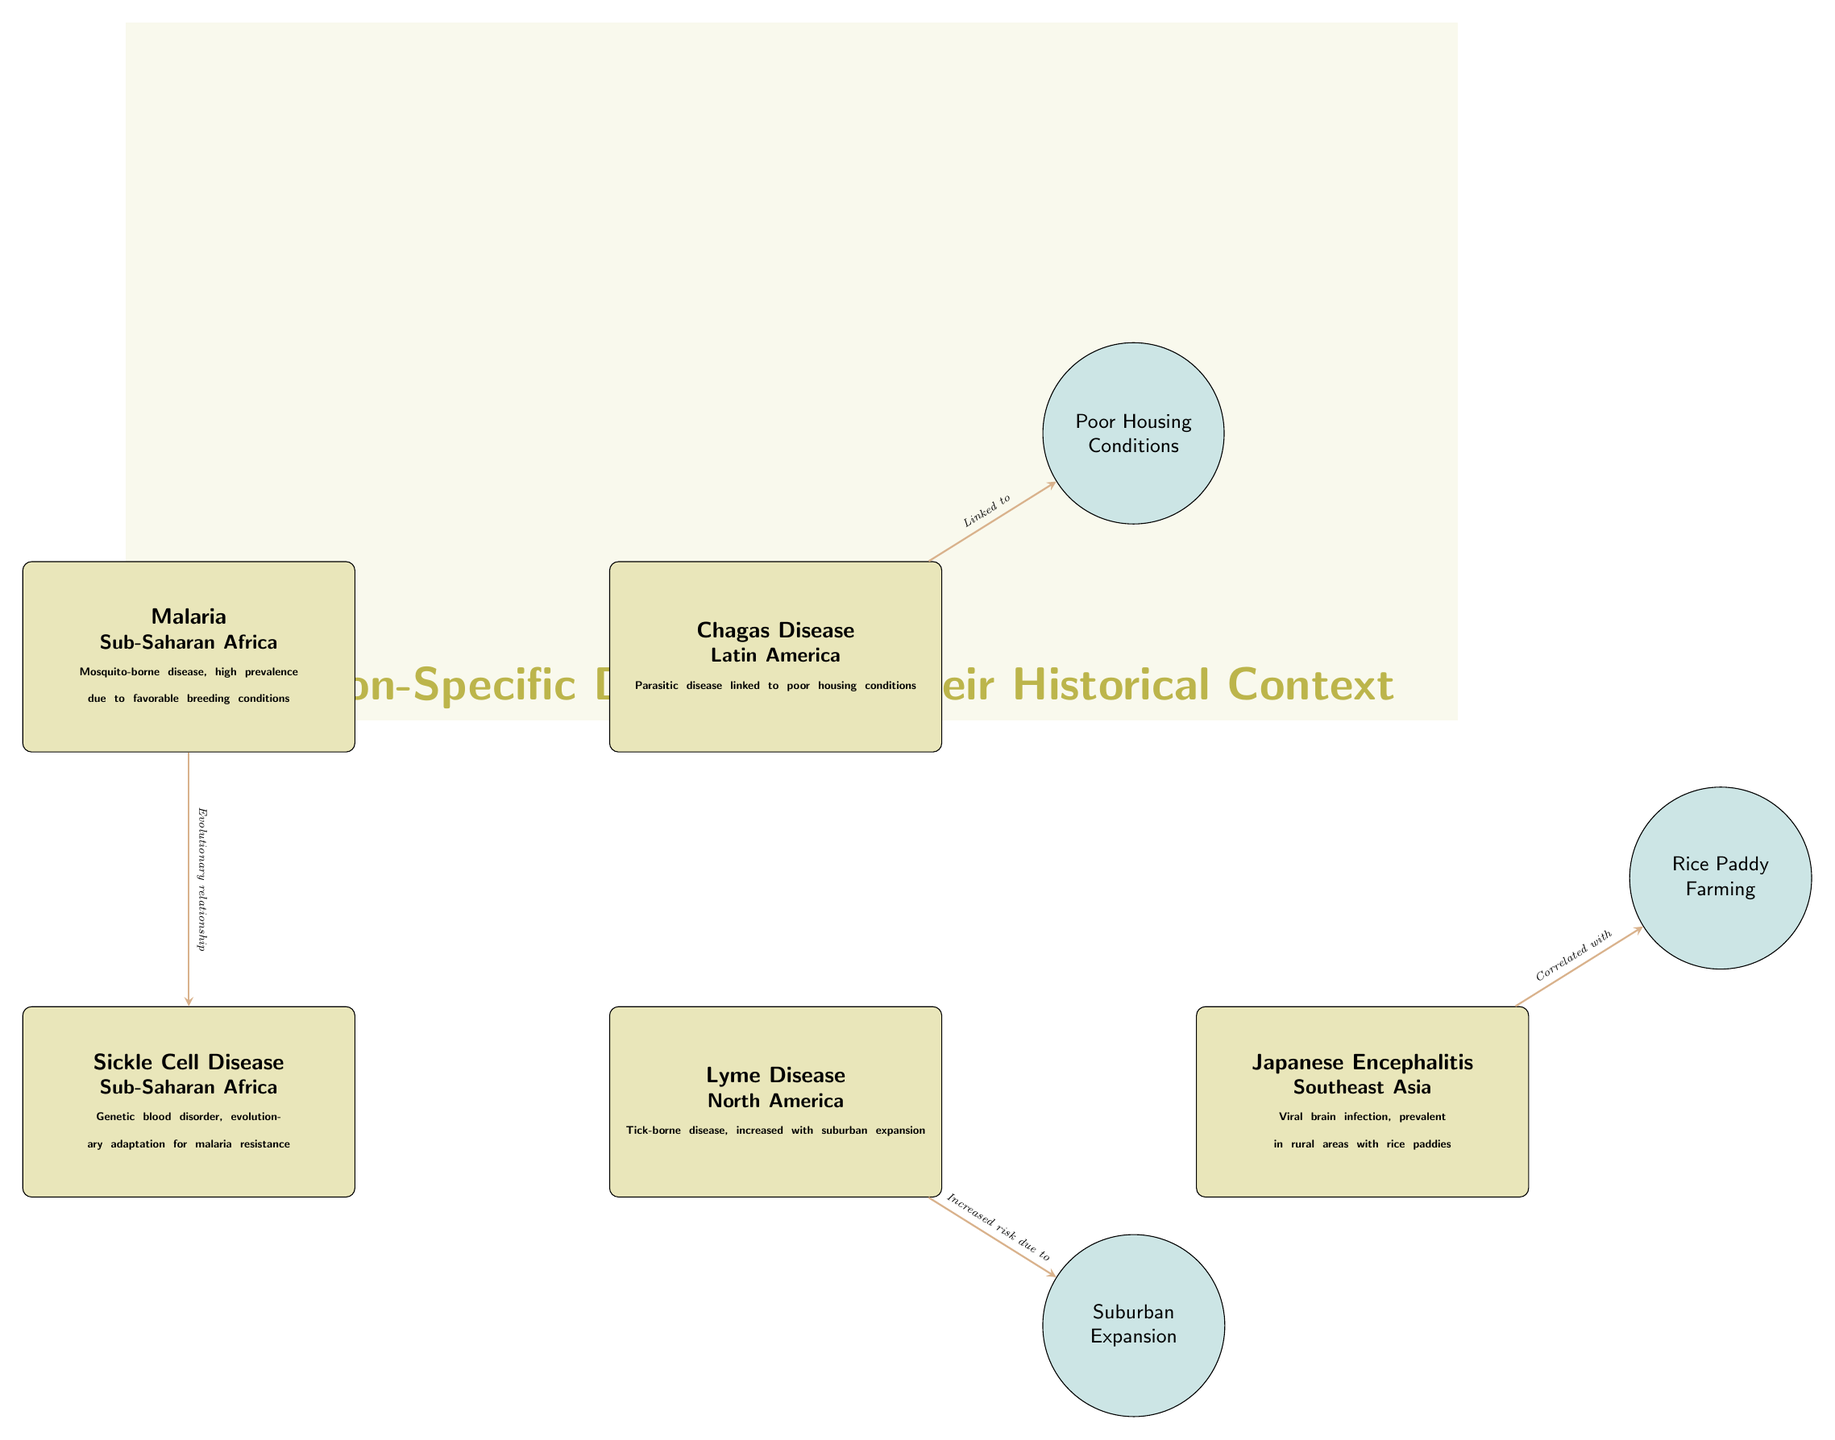What diseases are shown in the diagram? The diagram includes Malaria, Chagas Disease, Sickle Cell Disease, Lyme Disease, and Japanese Encephalitis. These diseases are listed in the nodes and their respective locations are visible alongside the descriptions.
Answer: Malaria, Chagas Disease, Sickle Cell Disease, Lyme Disease, Japanese Encephalitis Which disease is linked to poor housing conditions? Chagas Disease is associated with poor housing conditions as indicated by the connection from the Chagas node to the factor node labeled "Poor Housing Conditions."
Answer: Chagas Disease How many diseases are represented in the diagram? There are five distinct disease nodes in the diagram: Malaria, Chagas Disease, Sickle Cell Disease, Lyme Disease, and Japanese Encephalitis.
Answer: 5 What evolutionary relationship is displayed in the diagram? The diagram shows an evolutionary relationship between Malaria and Sickle Cell Disease, represented by the connection arrow labeled "Evolutionary relationship" between these two disease nodes.
Answer: Evolutionary relationship What factor correlates with Japanese Encephalitis? The diagram indicates that Japanese Encephalitis is correlated with Rice Paddy Farming, as shown by the connection to the factor node labeled "Rice Paddy Farming."
Answer: Rice Paddy Farming Which disease is increased due to suburban expansion? Lyme Disease is noted to have an increased risk due to suburban expansion, which is illustrated by the connection from the Lyme Disease node to the factor node labeled "Suburban Expansion."
Answer: Lyme Disease What region is associated with Sickle Cell Disease? Sickle Cell Disease is associated with Sub-Saharan Africa, as this information is stated directly below the disease name in its node.
Answer: Sub-Saharan Africa How is Chagas Disease specifically characterized in the diagram? The diagram characterizes Chagas Disease as a parasitic disease linked to poor housing conditions, as detailed in the node description below the disease title.
Answer: Parasitic disease linked to poor housing conditions What type of disease is Malaria described as? Malaria is described as a mosquito-borne disease with high prevalence due to favorable breeding conditions, which is included in the description underneath the disease name in its node.
Answer: Mosquito-borne disease 